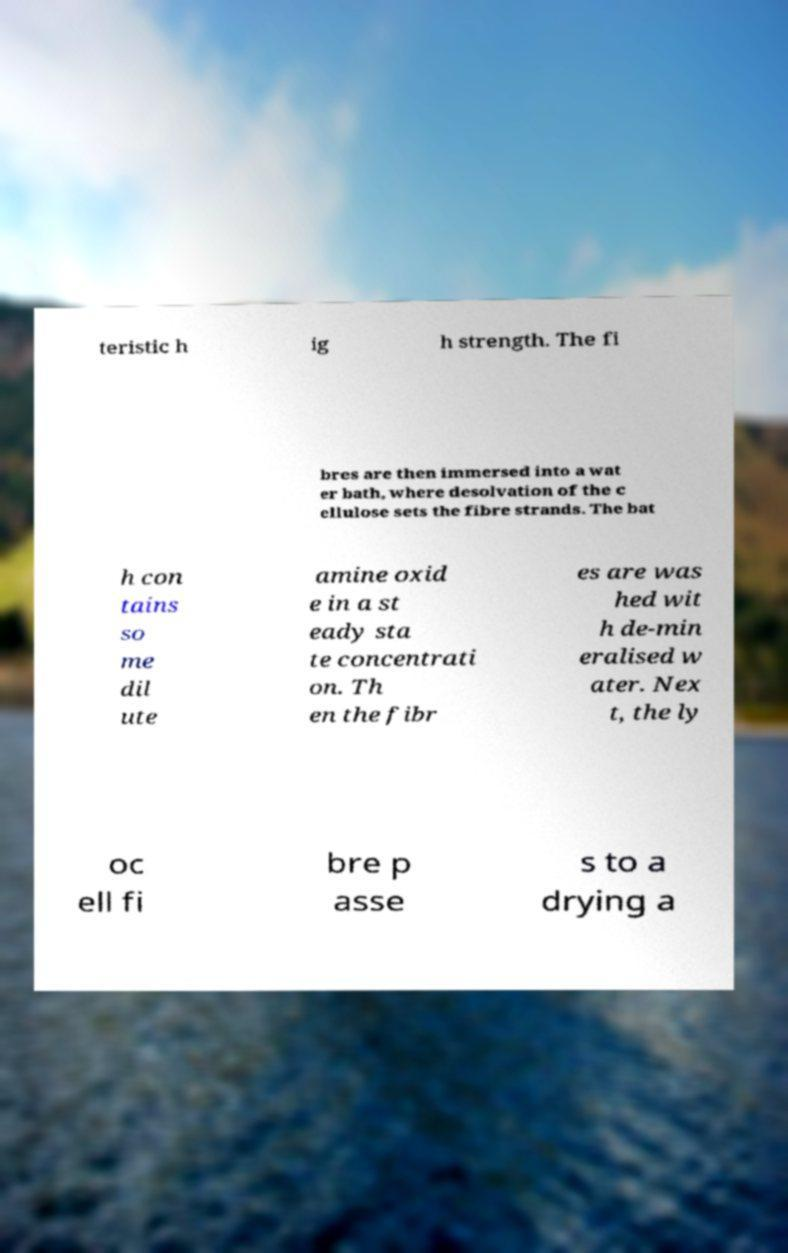Could you extract and type out the text from this image? teristic h ig h strength. The fi bres are then immersed into a wat er bath, where desolvation of the c ellulose sets the fibre strands. The bat h con tains so me dil ute amine oxid e in a st eady sta te concentrati on. Th en the fibr es are was hed wit h de-min eralised w ater. Nex t, the ly oc ell fi bre p asse s to a drying a 